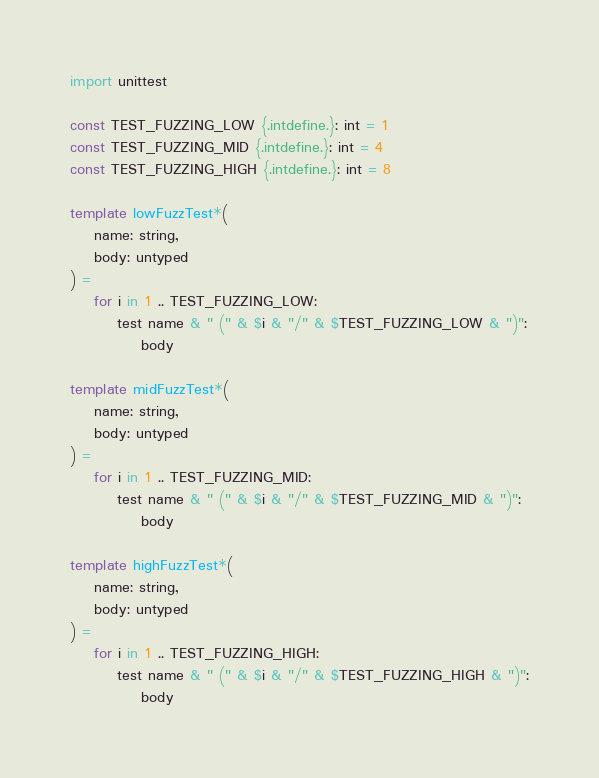<code> <loc_0><loc_0><loc_500><loc_500><_Nim_>import unittest

const TEST_FUZZING_LOW {.intdefine.}: int = 1
const TEST_FUZZING_MID {.intdefine.}: int = 4
const TEST_FUZZING_HIGH {.intdefine.}: int = 8

template lowFuzzTest*(
    name: string, 
    body: untyped
) =
    for i in 1 .. TEST_FUZZING_LOW:
        test name & " (" & $i & "/" & $TEST_FUZZING_LOW & ")":
            body

template midFuzzTest*(
    name: string, 
    body: untyped
) =
    for i in 1 .. TEST_FUZZING_MID:
        test name & " (" & $i & "/" & $TEST_FUZZING_MID & ")":
            body

template highFuzzTest*(
    name: string, 
    body: untyped
) =
    for i in 1 .. TEST_FUZZING_HIGH:
        test name & " (" & $i & "/" & $TEST_FUZZING_HIGH & ")":
            body
</code> 